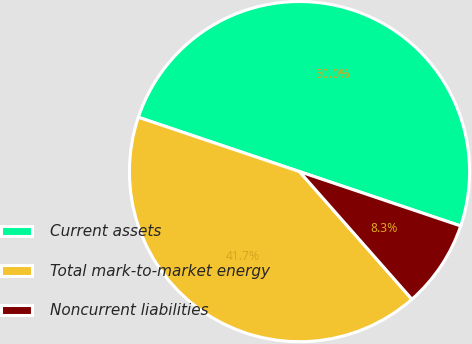Convert chart to OTSL. <chart><loc_0><loc_0><loc_500><loc_500><pie_chart><fcel>Current assets<fcel>Total mark-to-market energy<fcel>Noncurrent liabilities<nl><fcel>50.0%<fcel>41.67%<fcel>8.33%<nl></chart> 